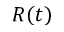Convert formula to latex. <formula><loc_0><loc_0><loc_500><loc_500>R ( t )</formula> 